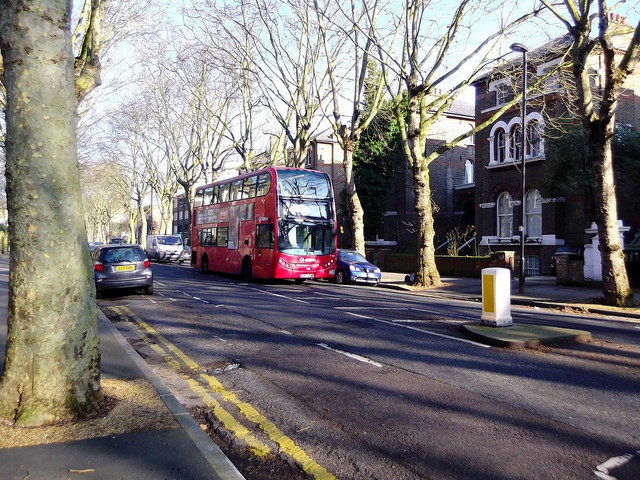Describe the objects in this image and their specific colors. I can see bus in black, maroon, gray, and white tones, car in black, gray, navy, and darkgray tones, car in black, gray, and white tones, truck in black, white, darkgray, and gray tones, and car in black, darkgray, gray, and lightgray tones in this image. 